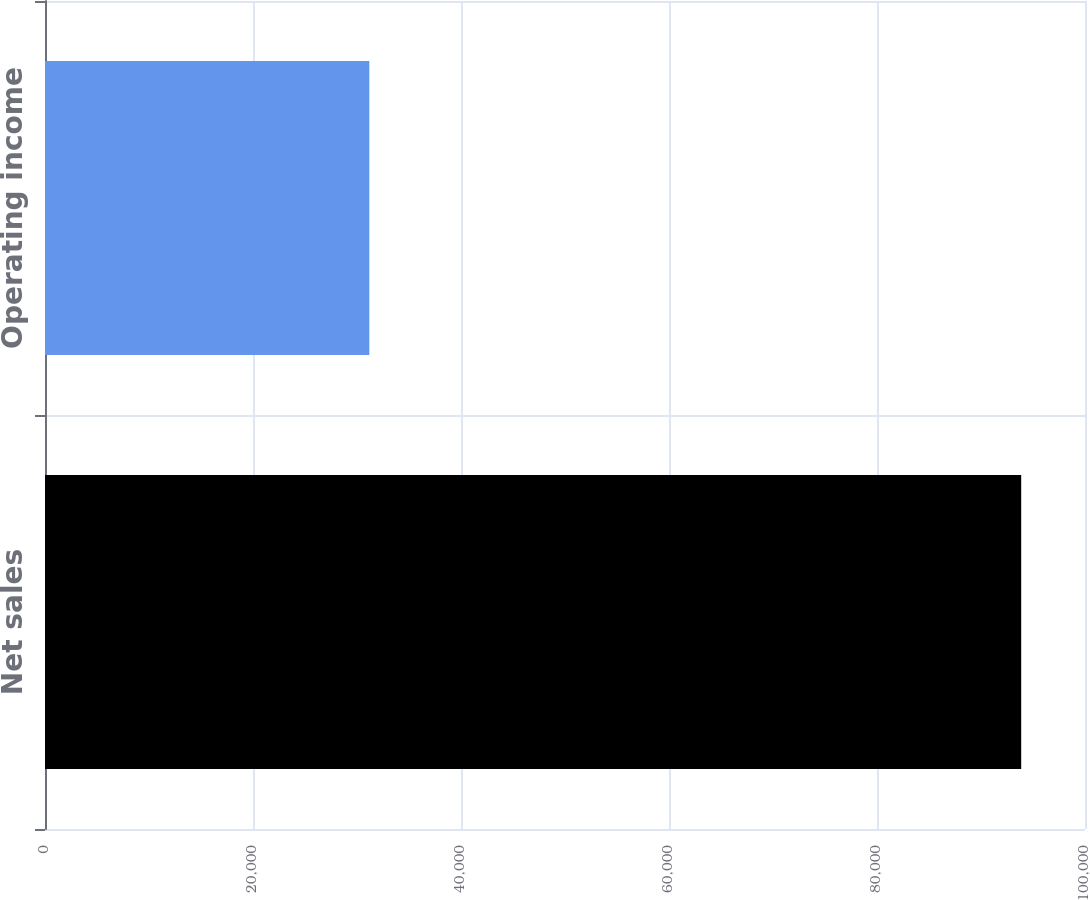Convert chart to OTSL. <chart><loc_0><loc_0><loc_500><loc_500><bar_chart><fcel>Net sales<fcel>Operating income<nl><fcel>93864<fcel>31186<nl></chart> 